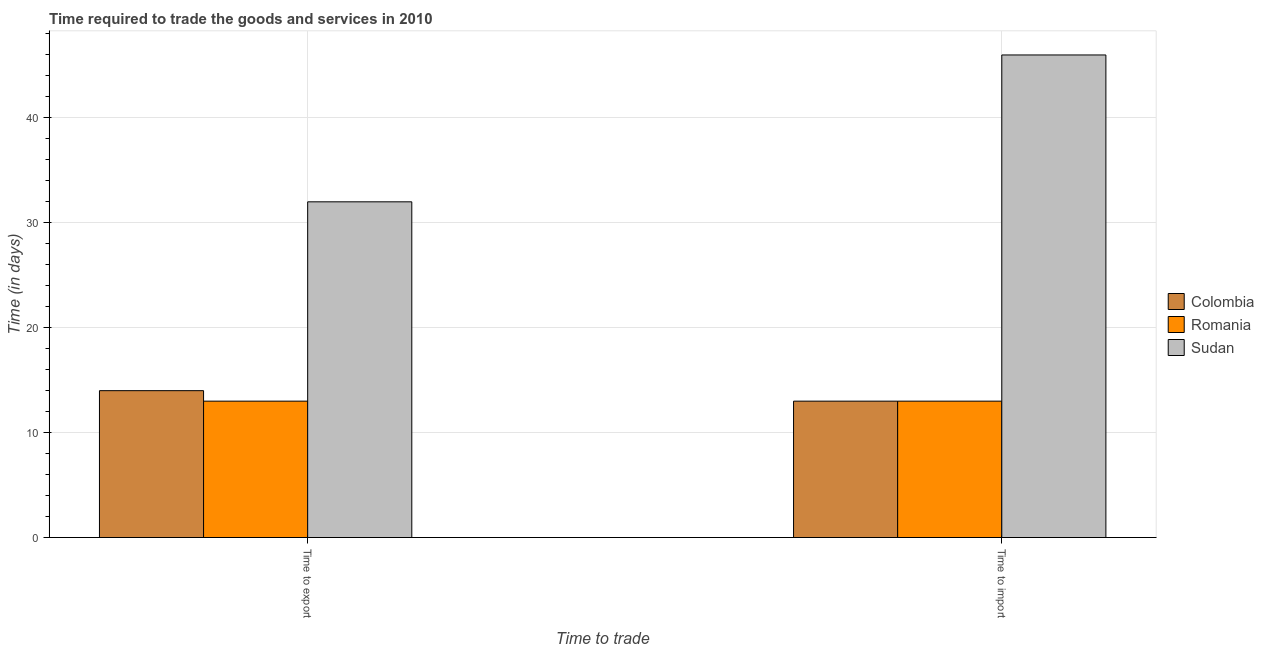How many bars are there on the 1st tick from the left?
Provide a short and direct response. 3. How many bars are there on the 2nd tick from the right?
Offer a terse response. 3. What is the label of the 2nd group of bars from the left?
Make the answer very short. Time to import. What is the time to export in Sudan?
Your answer should be compact. 32. Across all countries, what is the maximum time to import?
Offer a very short reply. 46. Across all countries, what is the minimum time to export?
Give a very brief answer. 13. In which country was the time to export maximum?
Your answer should be compact. Sudan. In which country was the time to export minimum?
Offer a very short reply. Romania. What is the total time to import in the graph?
Make the answer very short. 72. What is the difference between the time to export in Romania and that in Colombia?
Ensure brevity in your answer.  -1. What is the difference between the time to import in Colombia and the time to export in Romania?
Give a very brief answer. 0. What is the average time to export per country?
Keep it short and to the point. 19.67. What is the difference between the time to export and time to import in Colombia?
Give a very brief answer. 1. What is the ratio of the time to export in Colombia to that in Romania?
Provide a succinct answer. 1.08. In how many countries, is the time to import greater than the average time to import taken over all countries?
Offer a very short reply. 1. What does the 3rd bar from the left in Time to export represents?
Keep it short and to the point. Sudan. Does the graph contain any zero values?
Make the answer very short. No. What is the title of the graph?
Your response must be concise. Time required to trade the goods and services in 2010. Does "New Caledonia" appear as one of the legend labels in the graph?
Your response must be concise. No. What is the label or title of the X-axis?
Your response must be concise. Time to trade. What is the label or title of the Y-axis?
Offer a terse response. Time (in days). What is the Time (in days) in Romania in Time to export?
Offer a very short reply. 13. What is the Time (in days) in Sudan in Time to export?
Give a very brief answer. 32. Across all Time to trade, what is the maximum Time (in days) of Colombia?
Your answer should be compact. 14. Across all Time to trade, what is the maximum Time (in days) in Romania?
Your response must be concise. 13. Across all Time to trade, what is the maximum Time (in days) of Sudan?
Keep it short and to the point. 46. Across all Time to trade, what is the minimum Time (in days) in Colombia?
Your response must be concise. 13. Across all Time to trade, what is the minimum Time (in days) of Sudan?
Give a very brief answer. 32. What is the total Time (in days) in Romania in the graph?
Offer a very short reply. 26. What is the difference between the Time (in days) of Romania in Time to export and that in Time to import?
Give a very brief answer. 0. What is the difference between the Time (in days) in Colombia in Time to export and the Time (in days) in Romania in Time to import?
Offer a very short reply. 1. What is the difference between the Time (in days) in Colombia in Time to export and the Time (in days) in Sudan in Time to import?
Your answer should be compact. -32. What is the difference between the Time (in days) of Romania in Time to export and the Time (in days) of Sudan in Time to import?
Your response must be concise. -33. What is the average Time (in days) in Romania per Time to trade?
Offer a very short reply. 13. What is the difference between the Time (in days) in Romania and Time (in days) in Sudan in Time to export?
Provide a short and direct response. -19. What is the difference between the Time (in days) of Colombia and Time (in days) of Sudan in Time to import?
Provide a short and direct response. -33. What is the difference between the Time (in days) of Romania and Time (in days) of Sudan in Time to import?
Give a very brief answer. -33. What is the ratio of the Time (in days) of Colombia in Time to export to that in Time to import?
Your answer should be compact. 1.08. What is the ratio of the Time (in days) of Romania in Time to export to that in Time to import?
Make the answer very short. 1. What is the ratio of the Time (in days) in Sudan in Time to export to that in Time to import?
Make the answer very short. 0.7. What is the difference between the highest and the second highest Time (in days) in Colombia?
Your response must be concise. 1. What is the difference between the highest and the lowest Time (in days) in Colombia?
Offer a very short reply. 1. What is the difference between the highest and the lowest Time (in days) of Romania?
Give a very brief answer. 0. 